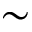<formula> <loc_0><loc_0><loc_500><loc_500>\sim</formula> 